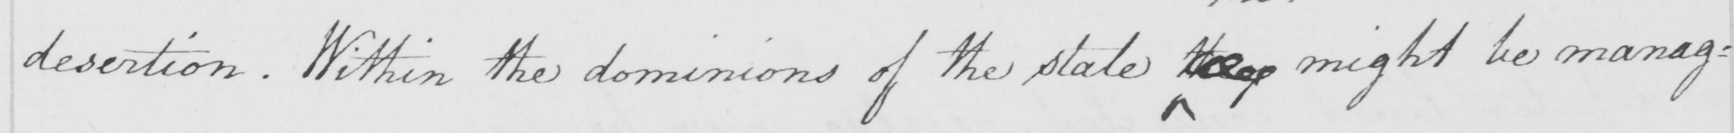What is written in this line of handwriting? desertion. Within the dominions of the state they  might be manag= 